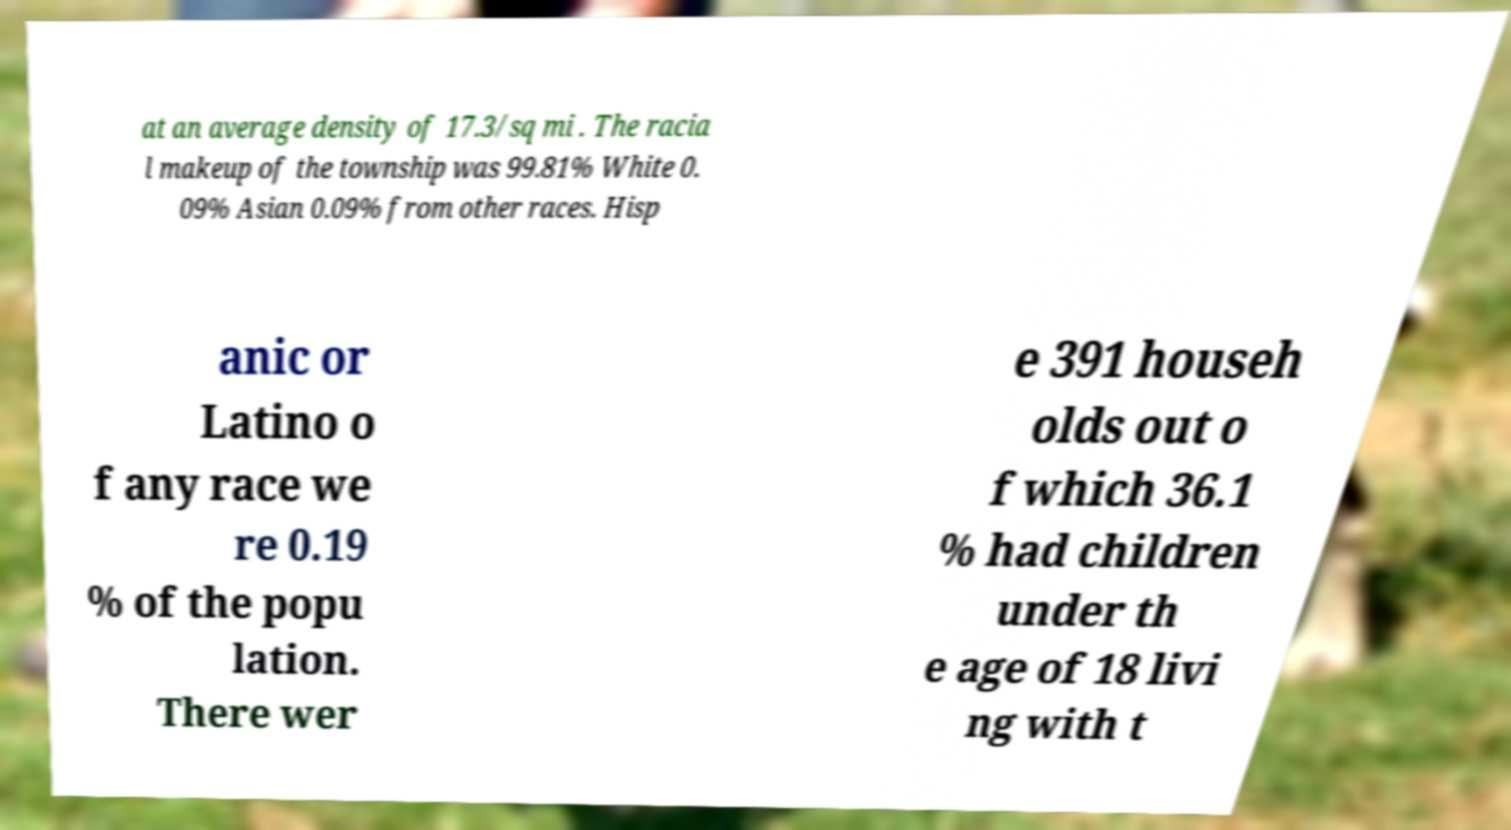Please read and relay the text visible in this image. What does it say? at an average density of 17.3/sq mi . The racia l makeup of the township was 99.81% White 0. 09% Asian 0.09% from other races. Hisp anic or Latino o f any race we re 0.19 % of the popu lation. There wer e 391 househ olds out o f which 36.1 % had children under th e age of 18 livi ng with t 